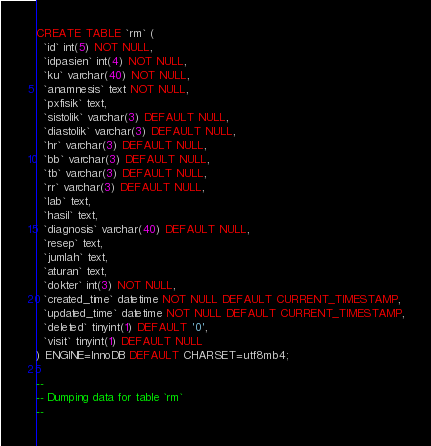Convert code to text. <code><loc_0><loc_0><loc_500><loc_500><_SQL_>CREATE TABLE `rm` (
  `id` int(5) NOT NULL,
  `idpasien` int(4) NOT NULL,
  `ku` varchar(40) NOT NULL,
  `anamnesis` text NOT NULL,
  `pxfisik` text,
  `sistolik` varchar(3) DEFAULT NULL,
  `diastolik` varchar(3) DEFAULT NULL,
  `hr` varchar(3) DEFAULT NULL,
  `bb` varchar(3) DEFAULT NULL,
  `tb` varchar(3) DEFAULT NULL,
  `rr` varchar(3) DEFAULT NULL,
  `lab` text,
  `hasil` text,
  `diagnosis` varchar(40) DEFAULT NULL,
  `resep` text,
  `jumlah` text,
  `aturan` text,
  `dokter` int(3) NOT NULL,
  `created_time` datetime NOT NULL DEFAULT CURRENT_TIMESTAMP,
  `updated_time` datetime NOT NULL DEFAULT CURRENT_TIMESTAMP,
  `deleted` tinyint(1) DEFAULT '0',
  `visit` tinyint(1) DEFAULT NULL
) ENGINE=InnoDB DEFAULT CHARSET=utf8mb4;

--
-- Dumping data for table `rm`
--
</code> 